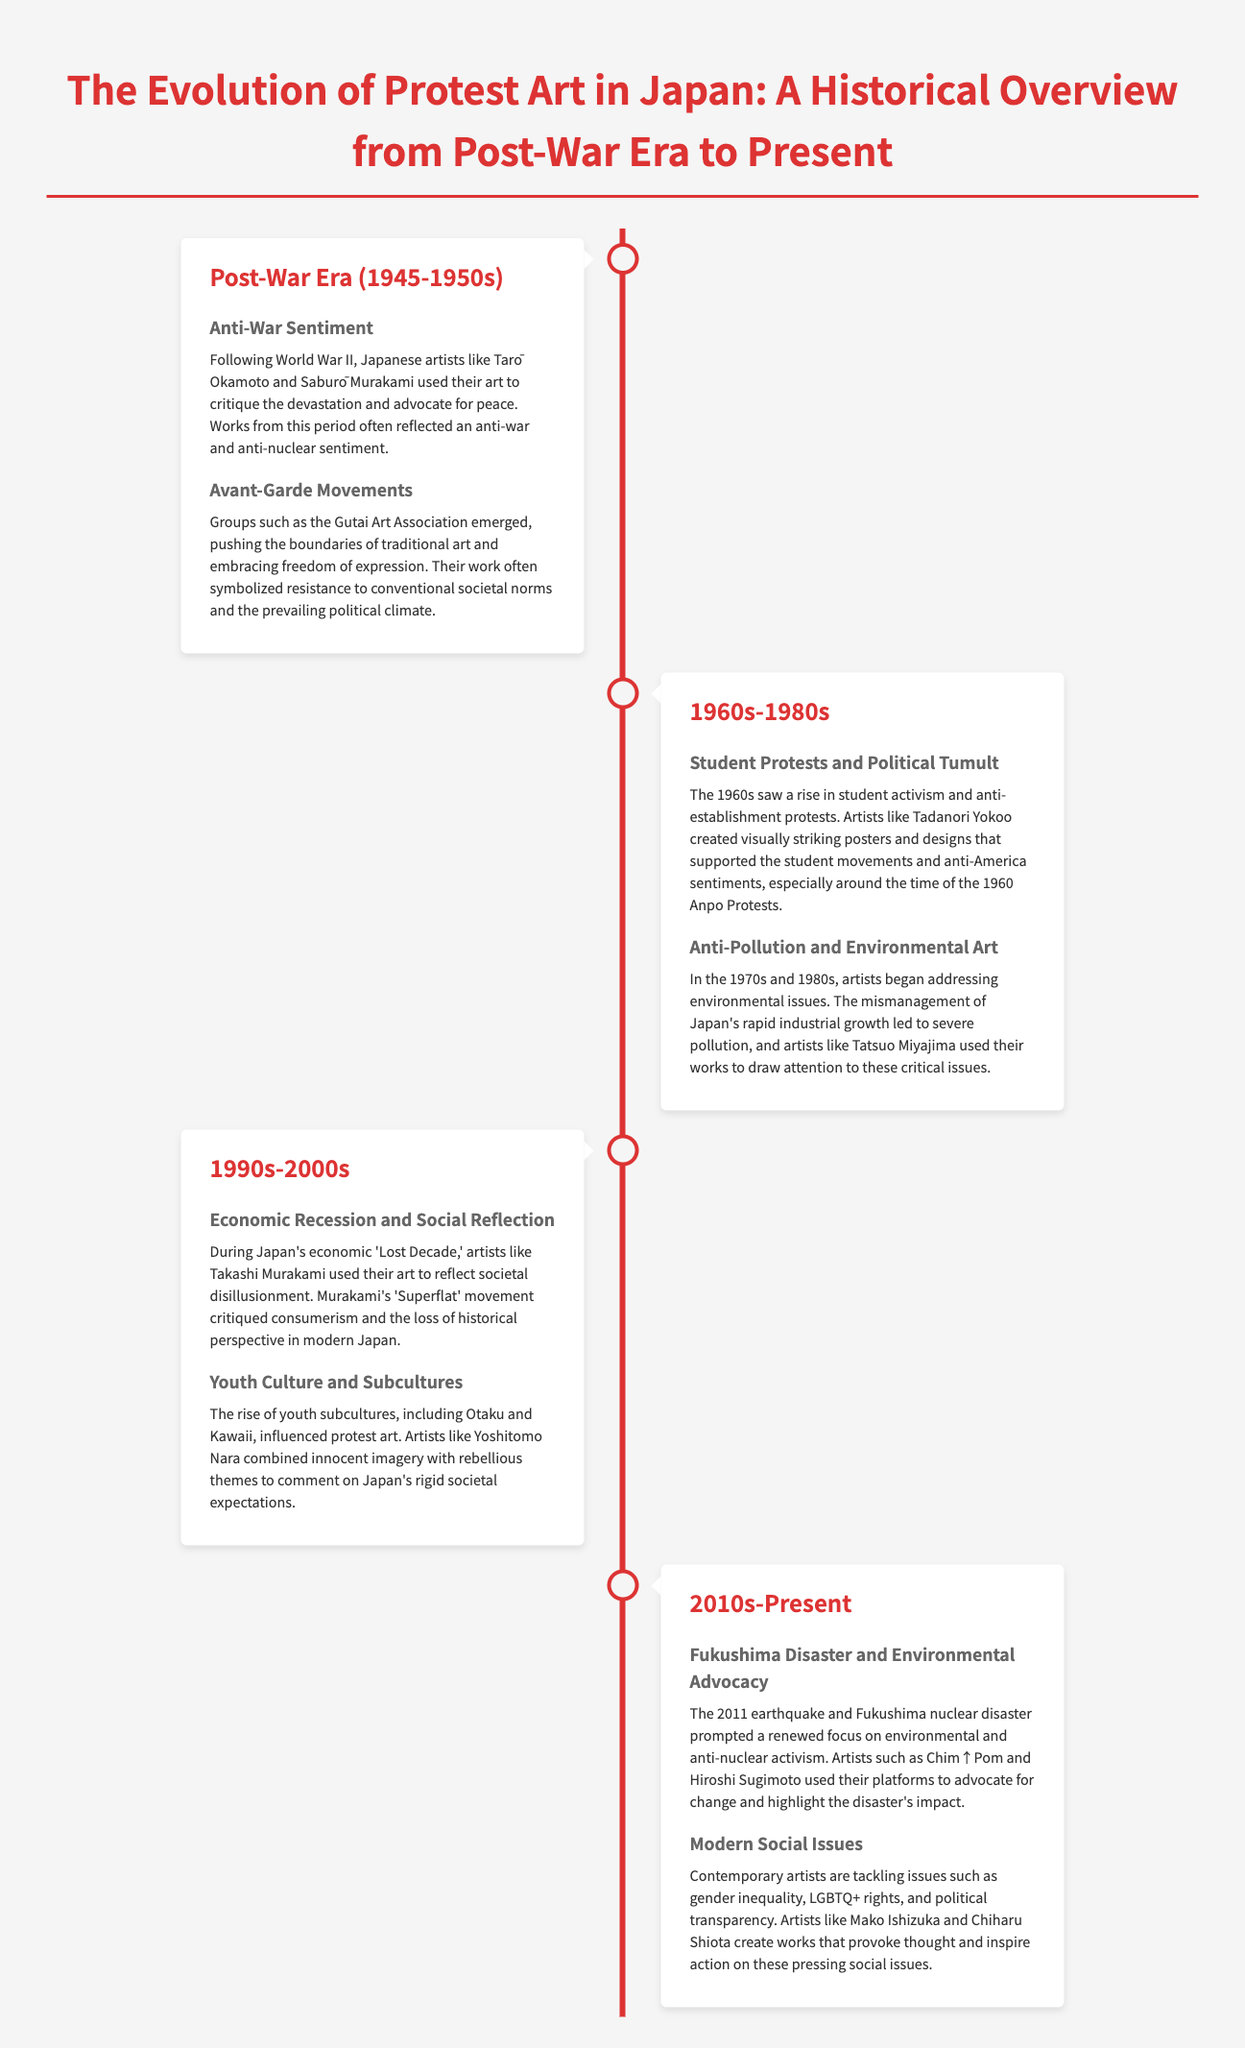What era does the infographic start from? The document states that the historical overview begins with the Post-War Era, marked by the year 1945.
Answer: 1945 Who were notable artists in the Post-War Era? The text mentions Tarō Okamoto and Saburō Murakami as key figures critiquing devastation and advocating for peace.
Answer: Tarō Okamoto and Saburō Murakami What significant event did Tadanori Yokoo support through his art? The document links Yokoo's work to the 1960 Anpo Protests, reflecting his support for student movements.
Answer: 1960 Anpo Protests Which movement did Takashi Murakami's art reflect during the 1990s? Murakami's work is associated with the critique of consumerism and the societal disillusionment during Japan's economic 'Lost Decade.'
Answer: Superflat What social issue is highlighted by contemporary artists? The infographic notes that modern artists tackle issues like gender inequality, LGBTQ+ rights, and political transparency.
Answer: Gender inequality, LGBTQ+ rights, and political transparency What art form emerged in the 1970s addressing pollution? The artwork from that time focused on anti-pollution themes due to severe environmental mismanagement.
Answer: Environmental Art In which time period did the Fukushima disaster significantly influence protest art? The Fukushima disaster's influence on protest art is noted in the section covering 2010s to Present.
Answer: 2010s What type of activism has Chim↑Pom focused on post-Fukushima? The document indicates that Chim↑Pom uses their platform for environmental and anti-nuclear advocacy.
Answer: Environmental and anti-nuclear advocacy Which group emerged in the Post-War Era to push artistic boundaries? The Gutai Art Association is identified as a key group in the Post-War Era focusing on avant-garde movements.
Answer: Gutai Art Association 